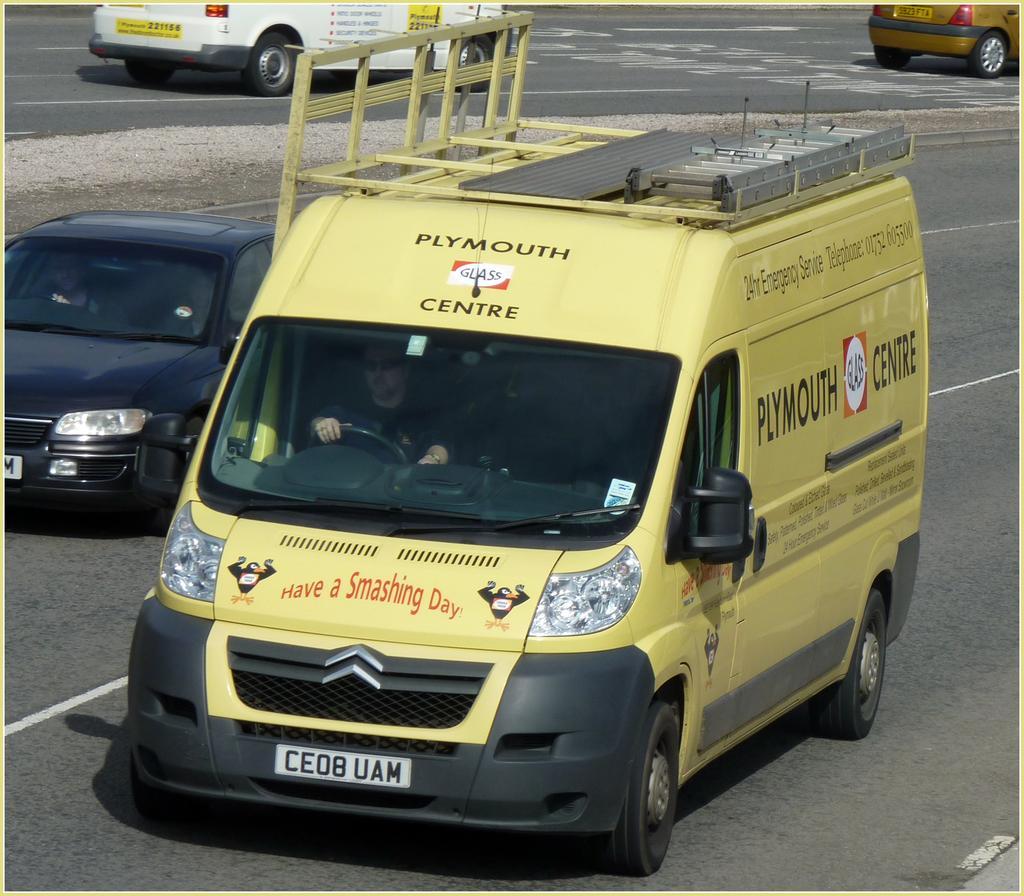How would you summarize this image in a sentence or two? In this picture i can see vehicles on the road. The van in the front is yellow in color and a person is sitting inside the van. I can also see white lines on the road. 